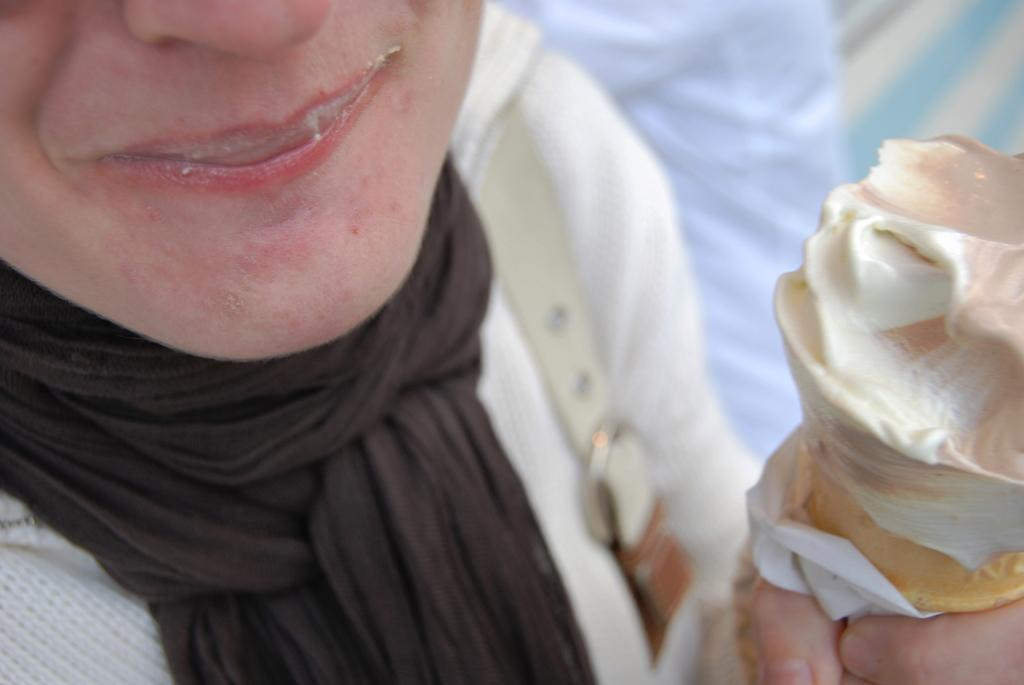Who is the main subject in the image? There is a lady in the image. What is the lady holding in the image? The lady is holding an ice-cream. Can you describe the lady's attire in the image? The lady is wearing a bag. What type of quilt is being discussed by the committee in the image? There is no committee or quilt present in the image; it features a lady holding an ice-cream and wearing a bag. 